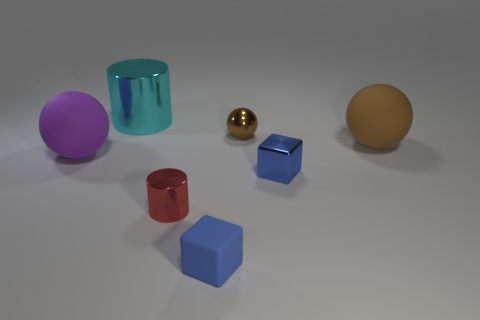Subtract 1 balls. How many balls are left? 2 Subtract all brown spheres. How many spheres are left? 1 Add 2 cyan rubber cylinders. How many objects exist? 9 Subtract all balls. How many objects are left? 4 Subtract 0 yellow cubes. How many objects are left? 7 Subtract all cyan cylinders. Subtract all purple rubber balls. How many objects are left? 5 Add 2 red cylinders. How many red cylinders are left? 3 Add 2 large cyan objects. How many large cyan objects exist? 3 